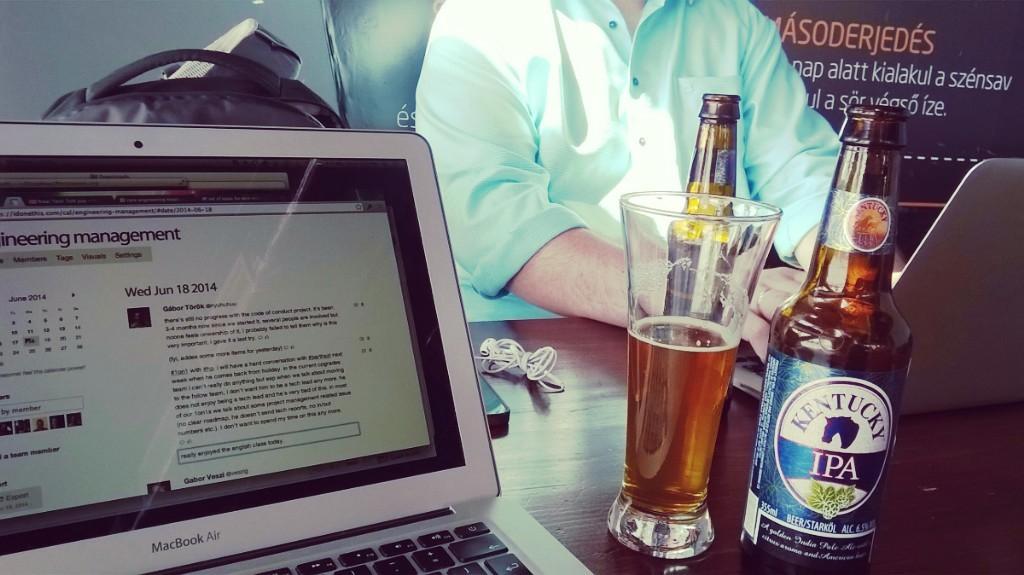What is the brand name of the alcohol?
Your answer should be compact. Kentucky ipa. 